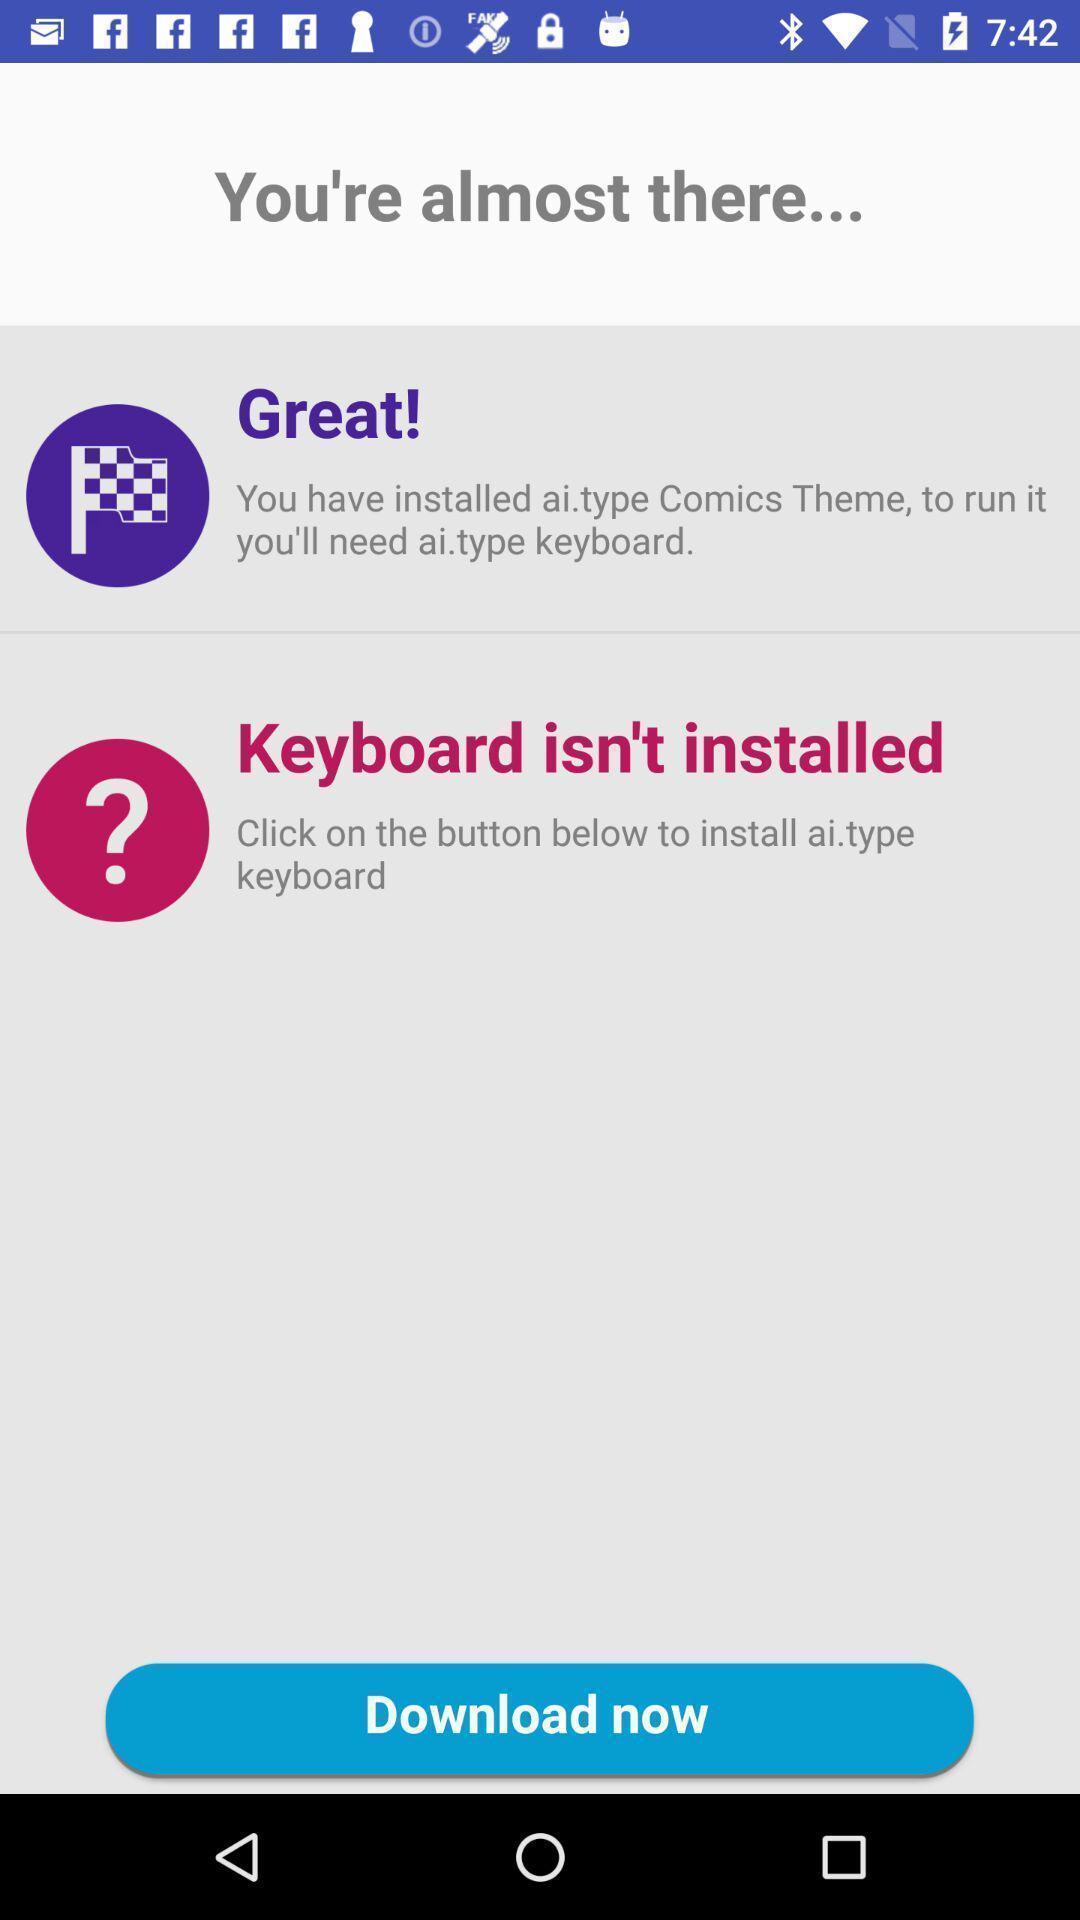Summarize the information in this screenshot. Page showing download keyboard app. 